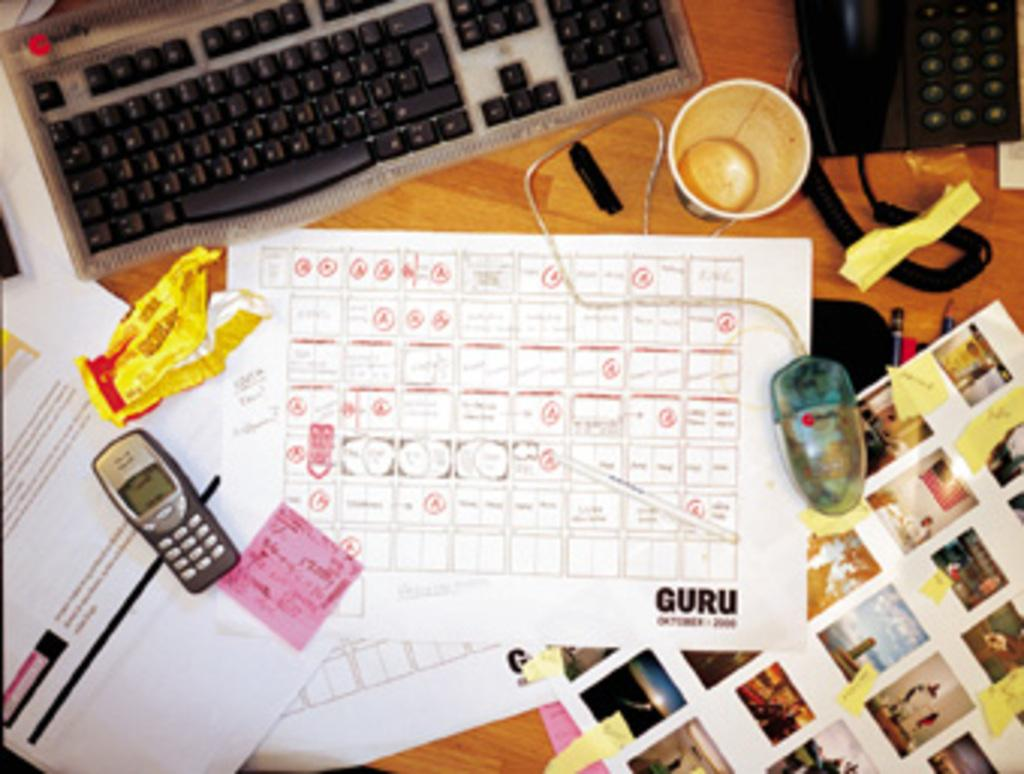What objects are present on the table in the image? There are papers, a computer, a telephone, cups, and a mobile phone on the table. Can you describe the type of device on the table? There is a computer on the table. What communication devices can be seen on the table? There is a telephone and a mobile phone on the table. What might be used for holding liquids on the table? There are cups on the table. What type of horn can be seen on the table in the image? There is no horn present on the table in the image. Is there a volcano visible in the image? No, there is no volcano present in the image. 